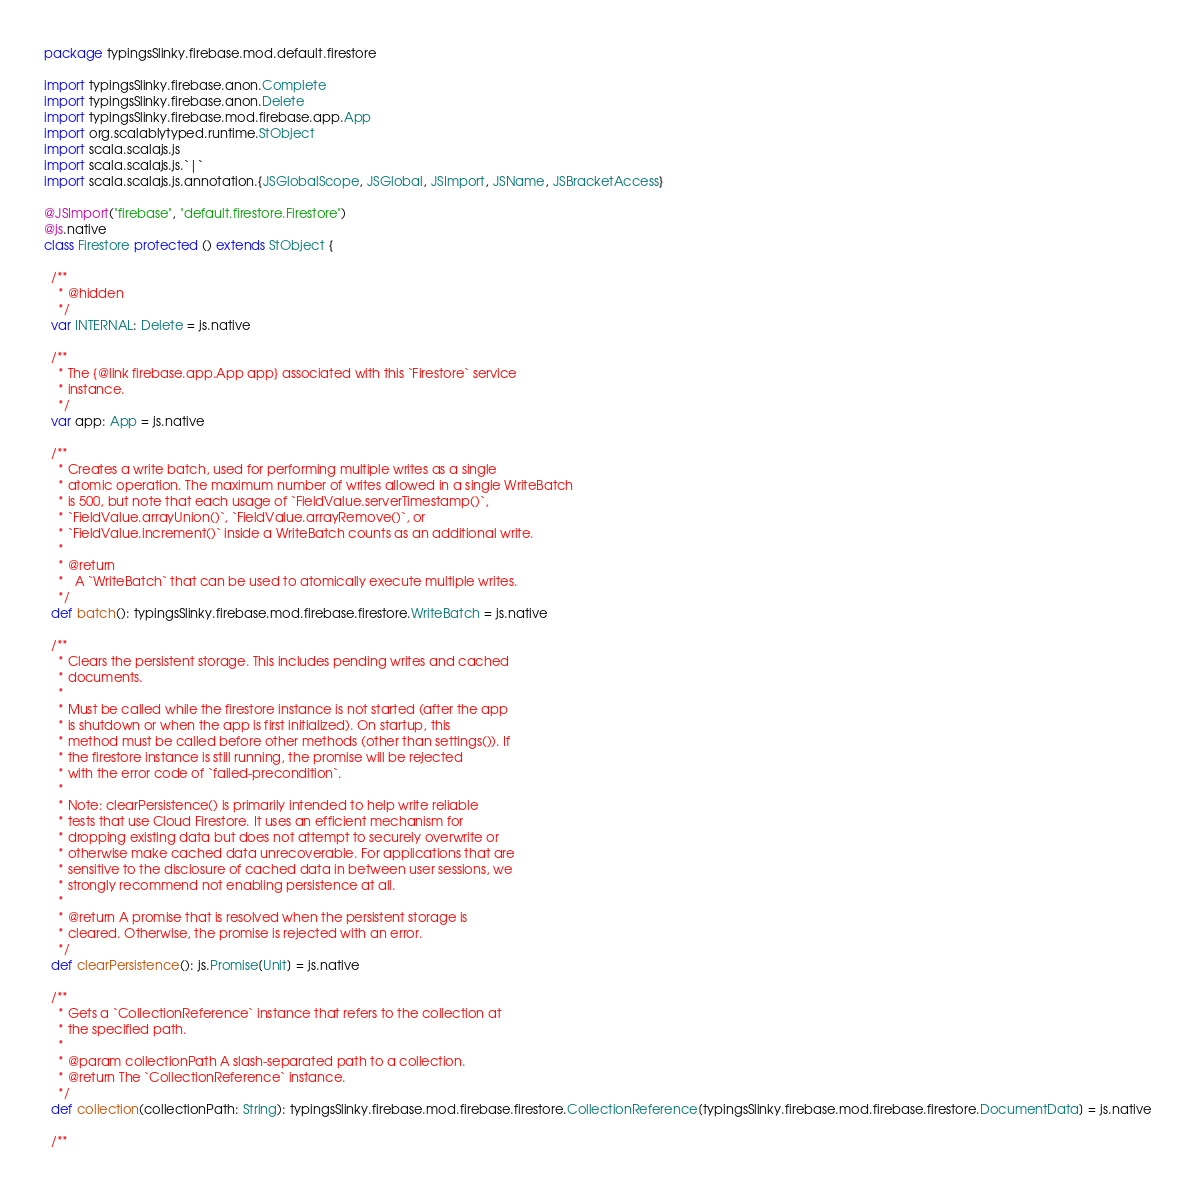Convert code to text. <code><loc_0><loc_0><loc_500><loc_500><_Scala_>package typingsSlinky.firebase.mod.default.firestore

import typingsSlinky.firebase.anon.Complete
import typingsSlinky.firebase.anon.Delete
import typingsSlinky.firebase.mod.firebase.app.App
import org.scalablytyped.runtime.StObject
import scala.scalajs.js
import scala.scalajs.js.`|`
import scala.scalajs.js.annotation.{JSGlobalScope, JSGlobal, JSImport, JSName, JSBracketAccess}

@JSImport("firebase", "default.firestore.Firestore")
@js.native
class Firestore protected () extends StObject {
  
  /**
    * @hidden
    */
  var INTERNAL: Delete = js.native
  
  /**
    * The {@link firebase.app.App app} associated with this `Firestore` service
    * instance.
    */
  var app: App = js.native
  
  /**
    * Creates a write batch, used for performing multiple writes as a single
    * atomic operation. The maximum number of writes allowed in a single WriteBatch
    * is 500, but note that each usage of `FieldValue.serverTimestamp()`,
    * `FieldValue.arrayUnion()`, `FieldValue.arrayRemove()`, or
    * `FieldValue.increment()` inside a WriteBatch counts as an additional write.
    *
    * @return
    *   A `WriteBatch` that can be used to atomically execute multiple writes.
    */
  def batch(): typingsSlinky.firebase.mod.firebase.firestore.WriteBatch = js.native
  
  /**
    * Clears the persistent storage. This includes pending writes and cached
    * documents.
    *
    * Must be called while the firestore instance is not started (after the app
    * is shutdown or when the app is first initialized). On startup, this
    * method must be called before other methods (other than settings()). If
    * the firestore instance is still running, the promise will be rejected
    * with the error code of `failed-precondition`.
    *
    * Note: clearPersistence() is primarily intended to help write reliable
    * tests that use Cloud Firestore. It uses an efficient mechanism for
    * dropping existing data but does not attempt to securely overwrite or
    * otherwise make cached data unrecoverable. For applications that are
    * sensitive to the disclosure of cached data in between user sessions, we
    * strongly recommend not enabling persistence at all.
    *
    * @return A promise that is resolved when the persistent storage is
    * cleared. Otherwise, the promise is rejected with an error.
    */
  def clearPersistence(): js.Promise[Unit] = js.native
  
  /**
    * Gets a `CollectionReference` instance that refers to the collection at
    * the specified path.
    *
    * @param collectionPath A slash-separated path to a collection.
    * @return The `CollectionReference` instance.
    */
  def collection(collectionPath: String): typingsSlinky.firebase.mod.firebase.firestore.CollectionReference[typingsSlinky.firebase.mod.firebase.firestore.DocumentData] = js.native
  
  /**</code> 